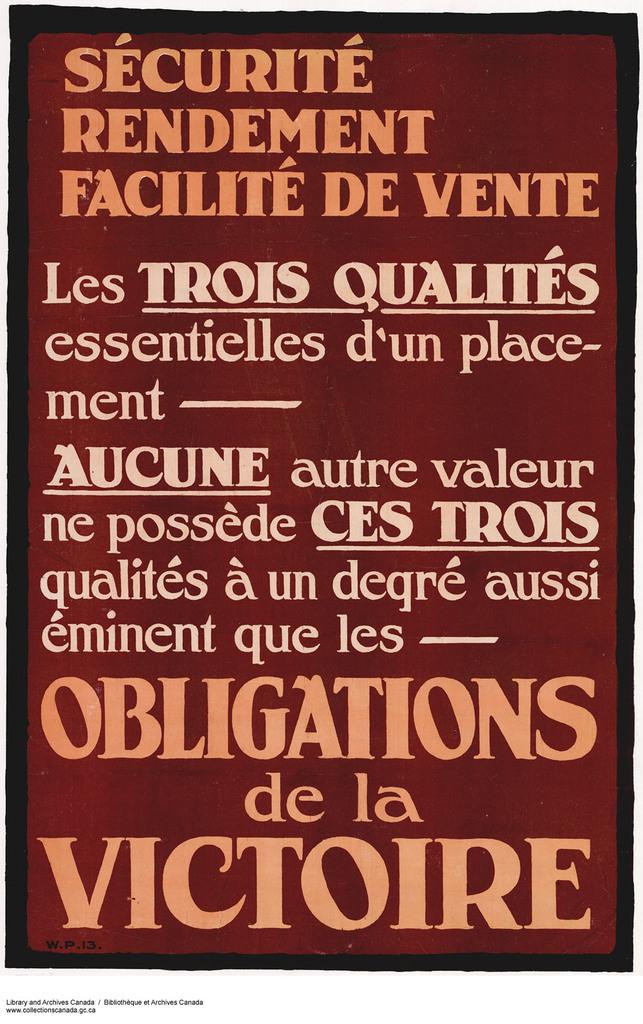Is the first word on the poster 'sécurité'?
Offer a terse response. Yes. What language is the sign written in?
Offer a terse response. Unanswerable. 